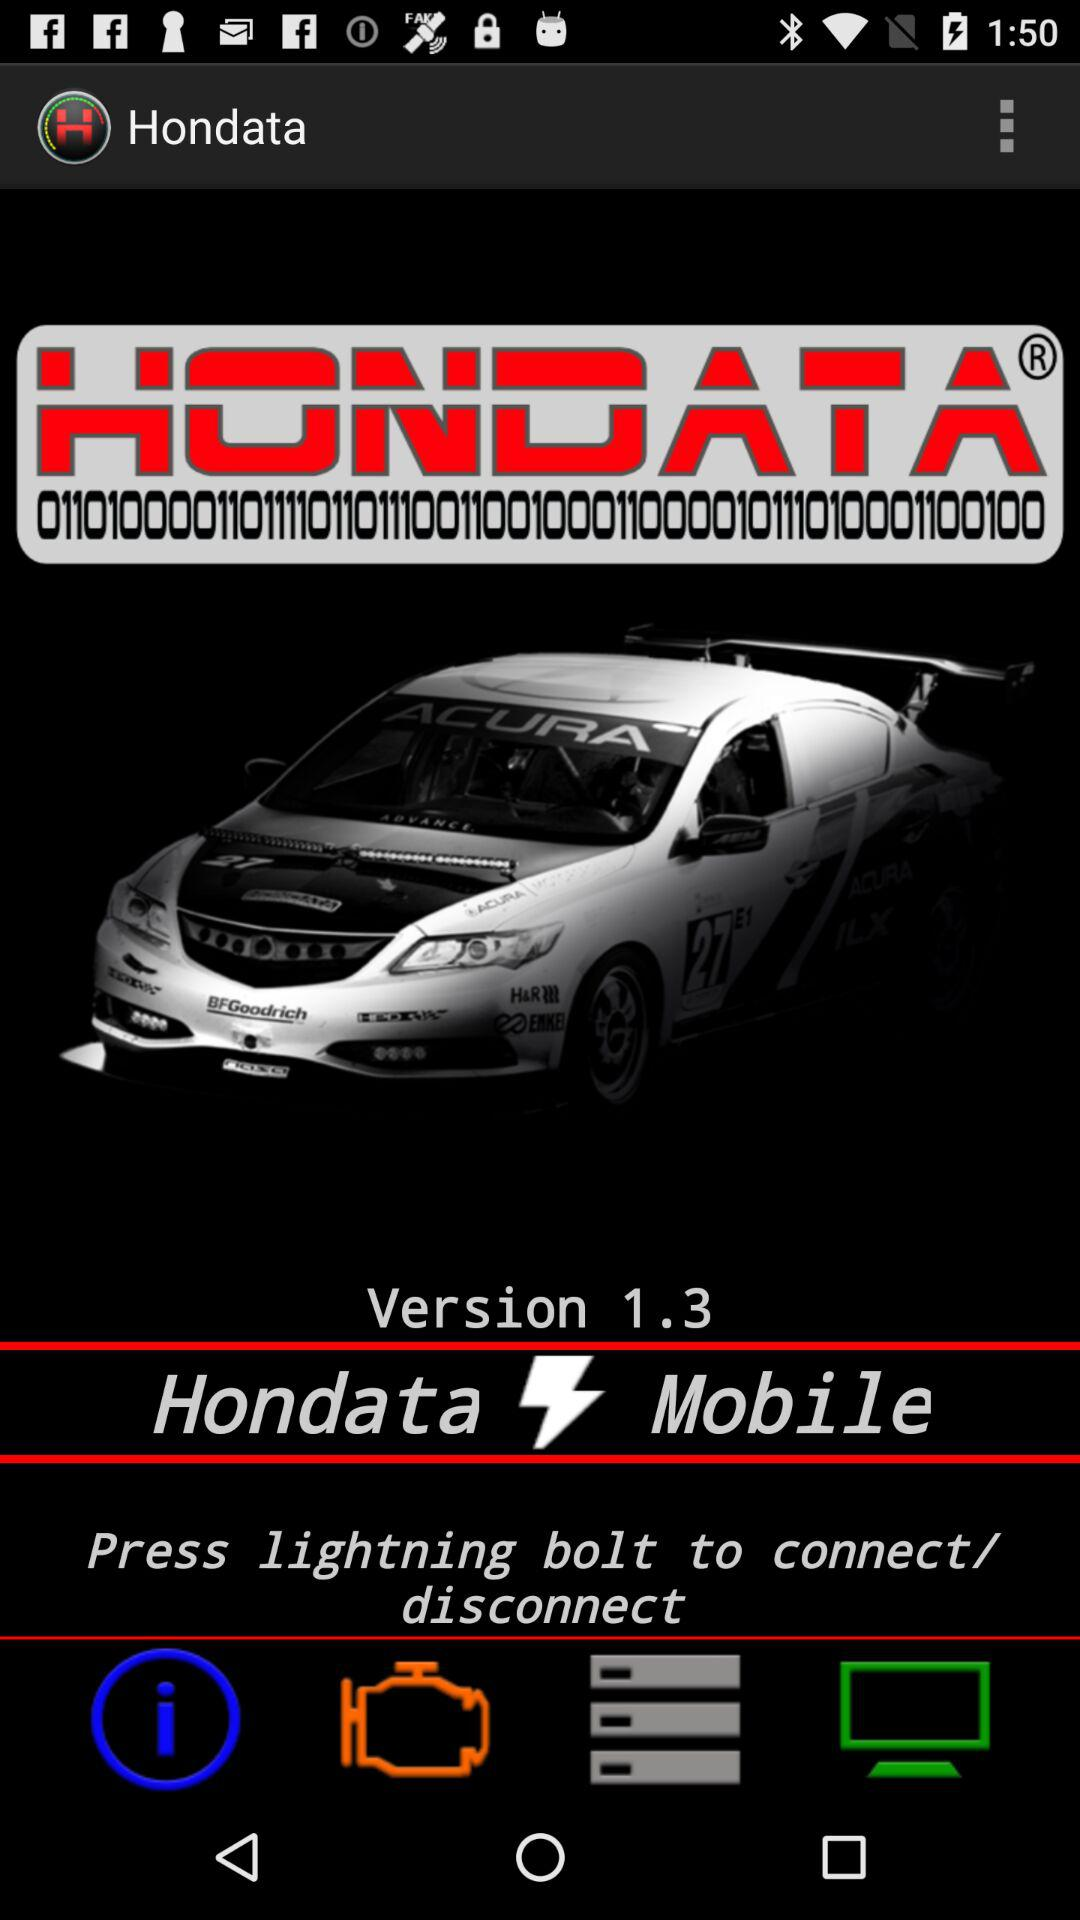What is the version of the app? The version of the app is 1.3. 